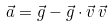Convert formula to latex. <formula><loc_0><loc_0><loc_500><loc_500>\vec { a } = \vec { g } - \vec { g } \cdot \vec { v } \, \vec { v }</formula> 